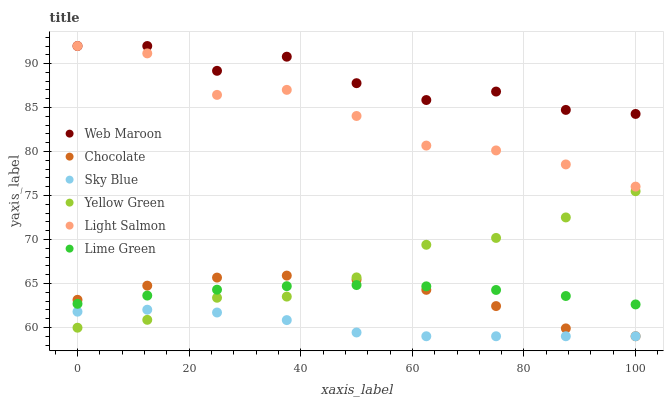Does Sky Blue have the minimum area under the curve?
Answer yes or no. Yes. Does Web Maroon have the maximum area under the curve?
Answer yes or no. Yes. Does Yellow Green have the minimum area under the curve?
Answer yes or no. No. Does Yellow Green have the maximum area under the curve?
Answer yes or no. No. Is Lime Green the smoothest?
Answer yes or no. Yes. Is Web Maroon the roughest?
Answer yes or no. Yes. Is Yellow Green the smoothest?
Answer yes or no. No. Is Yellow Green the roughest?
Answer yes or no. No. Does Chocolate have the lowest value?
Answer yes or no. Yes. Does Yellow Green have the lowest value?
Answer yes or no. No. Does Web Maroon have the highest value?
Answer yes or no. Yes. Does Yellow Green have the highest value?
Answer yes or no. No. Is Sky Blue less than Light Salmon?
Answer yes or no. Yes. Is Light Salmon greater than Chocolate?
Answer yes or no. Yes. Does Light Salmon intersect Web Maroon?
Answer yes or no. Yes. Is Light Salmon less than Web Maroon?
Answer yes or no. No. Is Light Salmon greater than Web Maroon?
Answer yes or no. No. Does Sky Blue intersect Light Salmon?
Answer yes or no. No. 